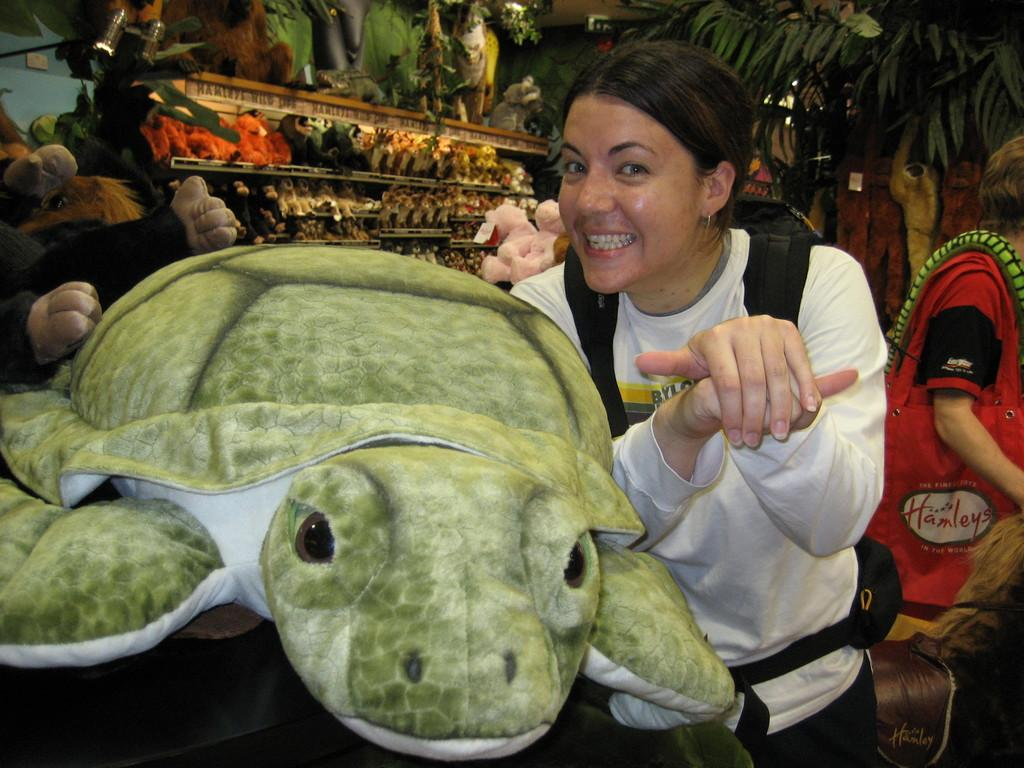Who is present in the image? There is a woman in the image. What is the woman doing in the image? The woman is smiling in the image. What can be seen near the woman? There is a soft toy near the woman. What else can be seen in the background of the image? There are more soft toys and people in the background of the image. What type of stamp can be seen on the woman's forehead in the image? There is no stamp visible on the woman's forehead in the image. What kind of thing is the woman holding in the image? The image does not show the woman holding any specific thing. 